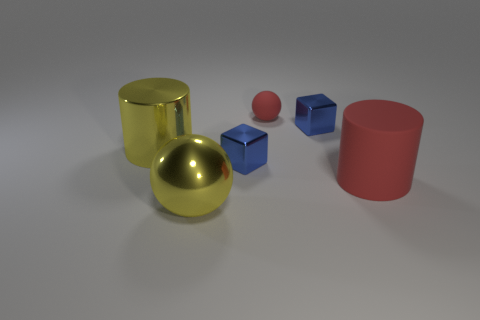Add 1 large yellow metal things. How many objects exist? 7 Subtract all spheres. How many objects are left? 4 Subtract all big yellow things. Subtract all small green matte cylinders. How many objects are left? 4 Add 4 small red things. How many small red things are left? 5 Add 1 yellow cylinders. How many yellow cylinders exist? 2 Subtract 0 gray balls. How many objects are left? 6 